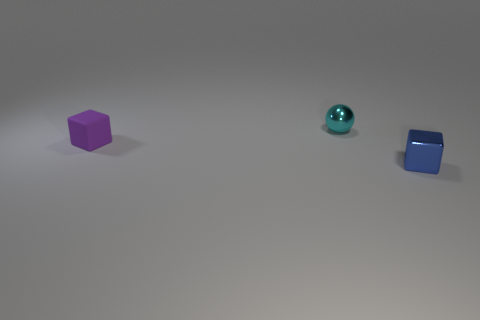Add 3 tiny matte objects. How many objects exist? 6 Subtract 1 purple cubes. How many objects are left? 2 Subtract all blocks. How many objects are left? 1 Subtract all gray blocks. Subtract all blue balls. How many blocks are left? 2 Subtract all red cylinders. How many purple blocks are left? 1 Subtract all tiny blocks. Subtract all large metal things. How many objects are left? 1 Add 2 tiny blue metallic blocks. How many tiny blue metallic blocks are left? 3 Add 1 cyan spheres. How many cyan spheres exist? 2 